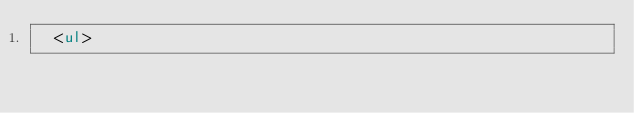Convert code to text. <code><loc_0><loc_0><loc_500><loc_500><_HTML_>  <ul></code> 